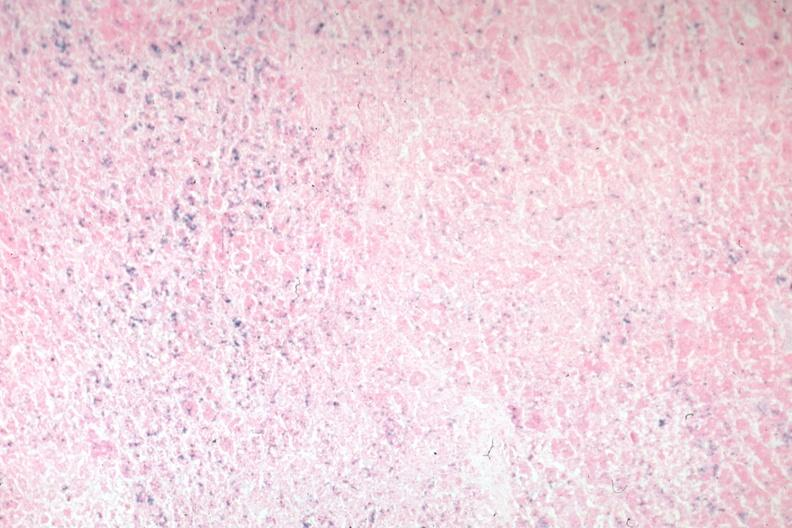does iron stain?
Answer the question using a single word or phrase. Yes 